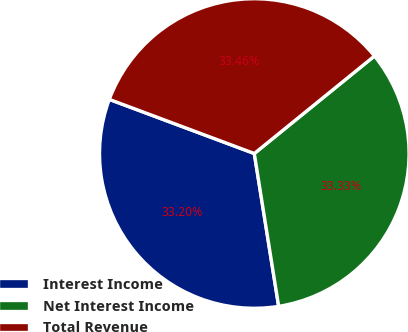Convert chart. <chart><loc_0><loc_0><loc_500><loc_500><pie_chart><fcel>Interest Income<fcel>Net Interest Income<fcel>Total Revenue<nl><fcel>33.2%<fcel>33.33%<fcel>33.46%<nl></chart> 